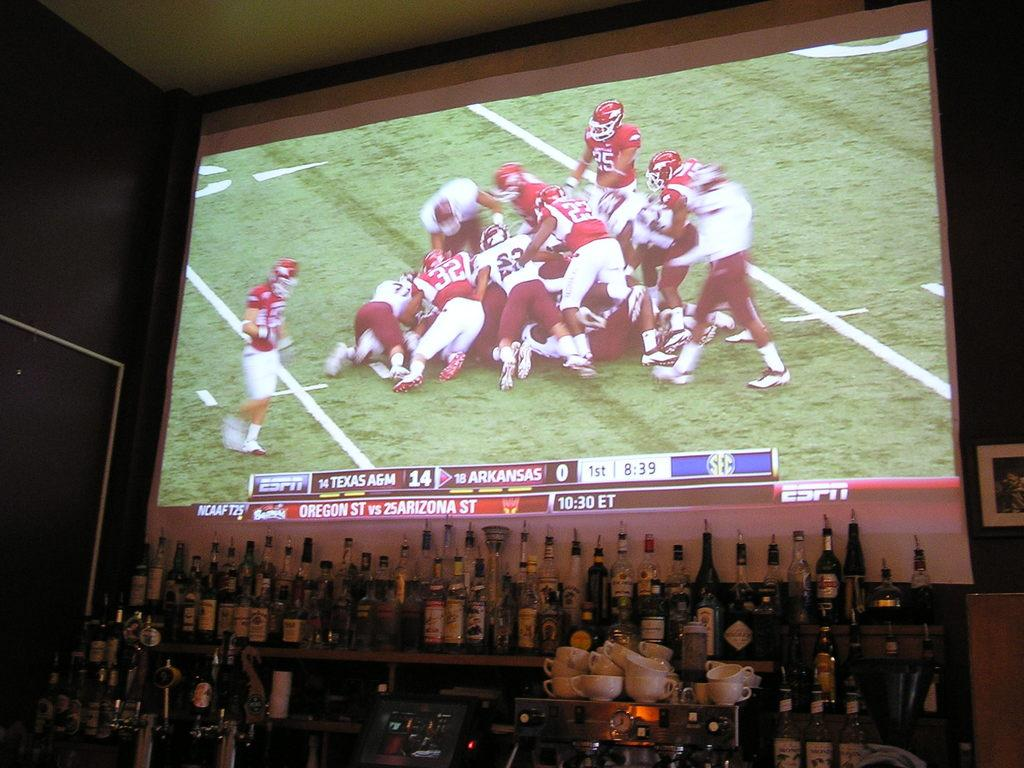<image>
Relay a brief, clear account of the picture shown. A TV behind a bar shows a football game between Texas A&M and Arkansas. 